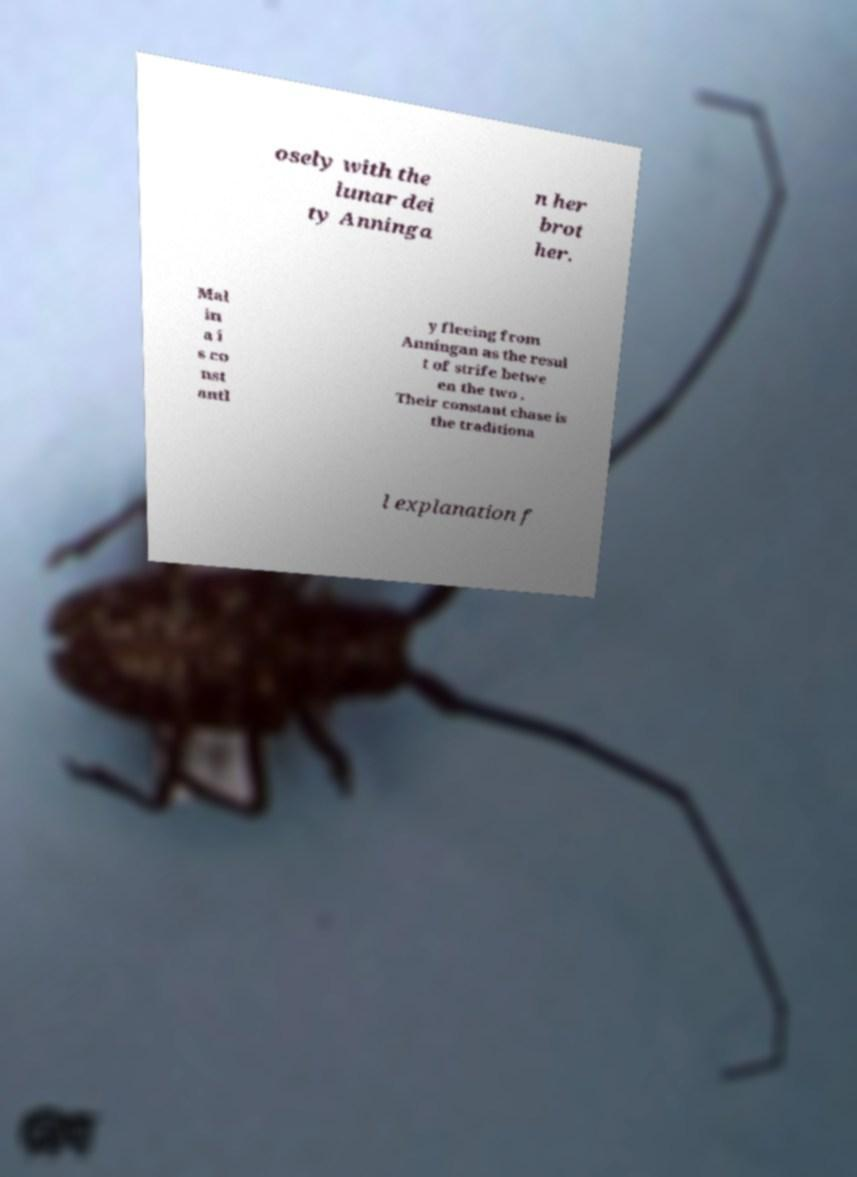Could you assist in decoding the text presented in this image and type it out clearly? osely with the lunar dei ty Anninga n her brot her. Mal in a i s co nst antl y fleeing from Anningan as the resul t of strife betwe en the two . Their constant chase is the traditiona l explanation f 